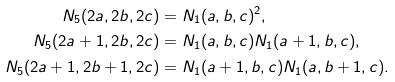<formula> <loc_0><loc_0><loc_500><loc_500>N _ { 5 } ( 2 a , 2 b , 2 c ) & = N _ { 1 } ( a , b , c ) ^ { 2 } , \\ N _ { 5 } ( 2 a + 1 , 2 b , 2 c ) & = N _ { 1 } ( a , b , c ) N _ { 1 } ( a + 1 , b , c ) , \\ N _ { 5 } ( 2 a + 1 , 2 b + 1 , 2 c ) & = N _ { 1 } ( a + 1 , b , c ) N _ { 1 } ( a , b + 1 , c ) .</formula> 